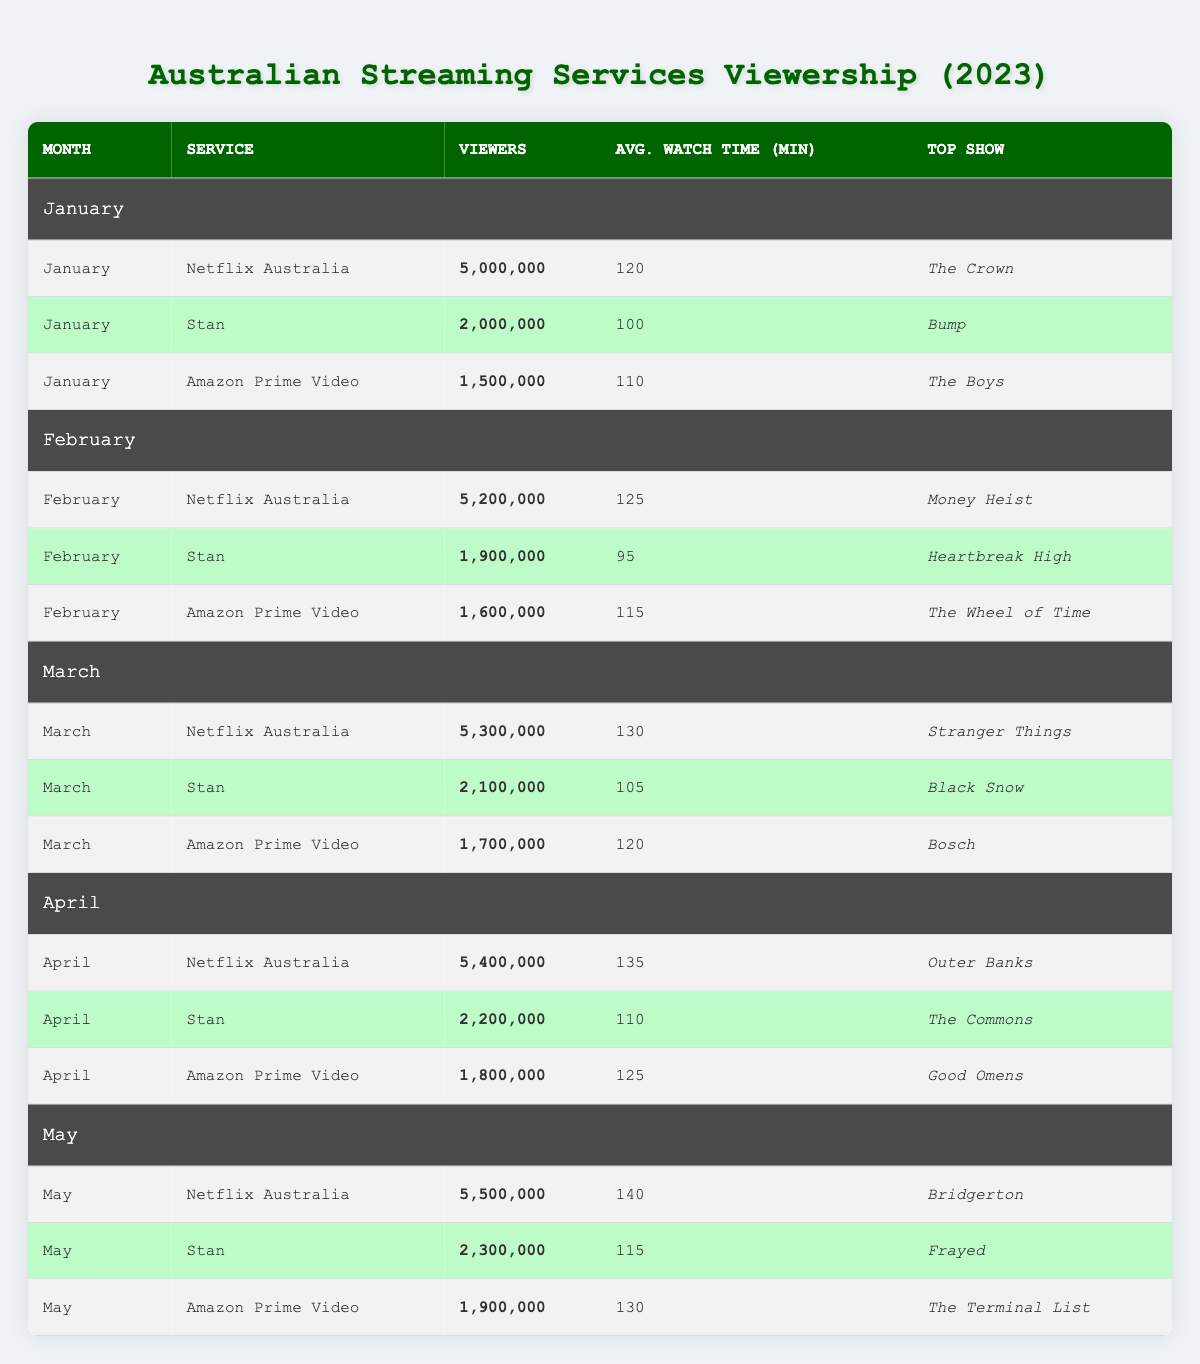What was the top show on Netflix Australia in January? Looking at the table, for January, the top show listed under Netflix Australia is "The Crown."
Answer: The Crown Which streaming service had the highest average watch time per user in May? In May, Netflix Australia had an average watch time of 140 minutes, Stan had 115 minutes, and Amazon Prime Video had 130 minutes. Therefore, Netflix Australia had the highest average watch time per user.
Answer: Netflix Australia How many total viewers did Stan have from January to May? The total viewers for Stan in each month are as follows: January (2,000,000) + February (1,900,000) + March (2,100,000) + April (2,200,000) + May (2,300,000). Adding these gives a total of 2,000,000 + 1,900,000 + 2,100,000 + 2,200,000 + 2,300,000 = 10,500,000 viewers.
Answer: 10,500,000 Which month had the lowest number of viewers for Amazon Prime Video? Looking through the data for Amazon Prime Video, January had 1,500,000 viewers, February had 1,600,000 viewers, March had 1,700,000 viewers, April had 1,800,000 viewers, and May had 1,900,000 viewers. January has the lowest number of viewers.
Answer: January What was the average number of viewers for Netflix Australia over the five months? The number of viewers for Netflix Australia over the five months are: January (5,000,000), February (5,200,000), March (5,300,000), April (5,400,000), and May (5,500,000). Summing these gives 5,000,000 + 5,200,000 + 5,300,000 + 5,400,000 + 5,500,000 = 26,400,000. Dividing this total by 5 gives an average of 26,400,000 / 5 = 5,280,000 viewers.
Answer: 5,280,000 Did Amazon Prime Video ever surpass Stan in viewership during the months observed? In January, Amazon Prime Video had 1,500,000 viewers while Stan had 2,000,000; in February, Amazon had 1,600,000 and Stan 1,900,000; in March, Amazon had 1,700,000 and Stan had 2,100,000; in April, Amazon had 1,800,000 and Stan had 2,200,000; in May, Amazon had 1,900,000 and Stan had 2,300,000. Amazon Prime Video did not surpass Stan in any month.
Answer: No Which month's total viewership across all services was the highest? The total viewership for each month are: January (5,000,000 + 2,000,000 + 1,500,000 = 8,500,000), February (5,200,000 + 1,900,000 + 1,600,000 = 8,700,000), March (5,300,000 + 2,100,000 + 1,700,000 = 9,100,000), April (5,400,000 + 2,200,000 + 1,800,000 = 9,400,000), and May (5,500,000 + 2,300,000 + 1,900,000 = 9,700,000). The highest total is for May, which sums to 9,700,000.
Answer: May What was the difference in average watch time between the highest and lowest for Stan across the months observed? For Stan: January (100), February (95), March (105), April (110), May (115). The highest average watch time is 115 (May) and the lowest is 95 (February). The difference is 115 - 95 = 20 minutes.
Answer: 20 minutes Which service consistently had the most viewers throughout the months? Examining the data, Netflix Australia consistently had the highest viewers each month with 5,000,000 in January, 5,200,000 in February, 5,300,000 in March, 5,400,000 in April, and 5,500,000 in May.
Answer: Netflix Australia 